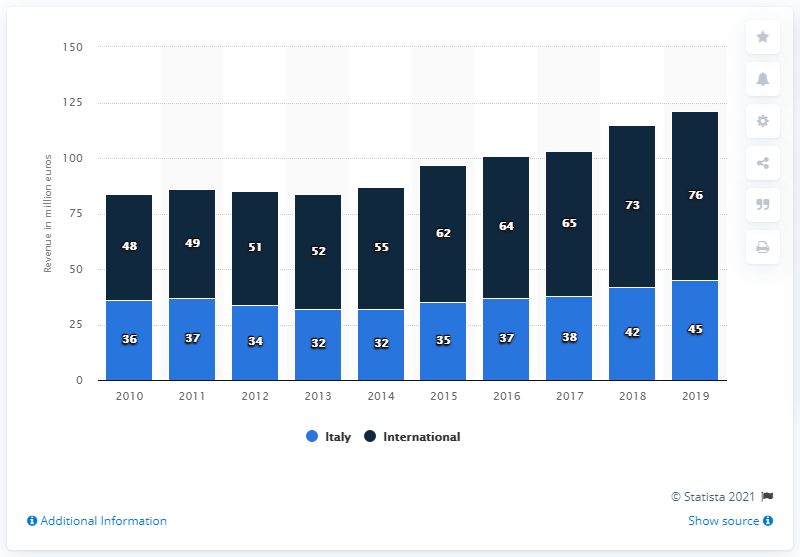Give some essential details in this illustration. According to the sales in the foreign market, 76% of the total sales were made by the Italian winery Compagnia de' Frescobaldi. In 2019, Italy had the largest revenue among all the years. For all years, the average revenue of Italy is 36.8. 